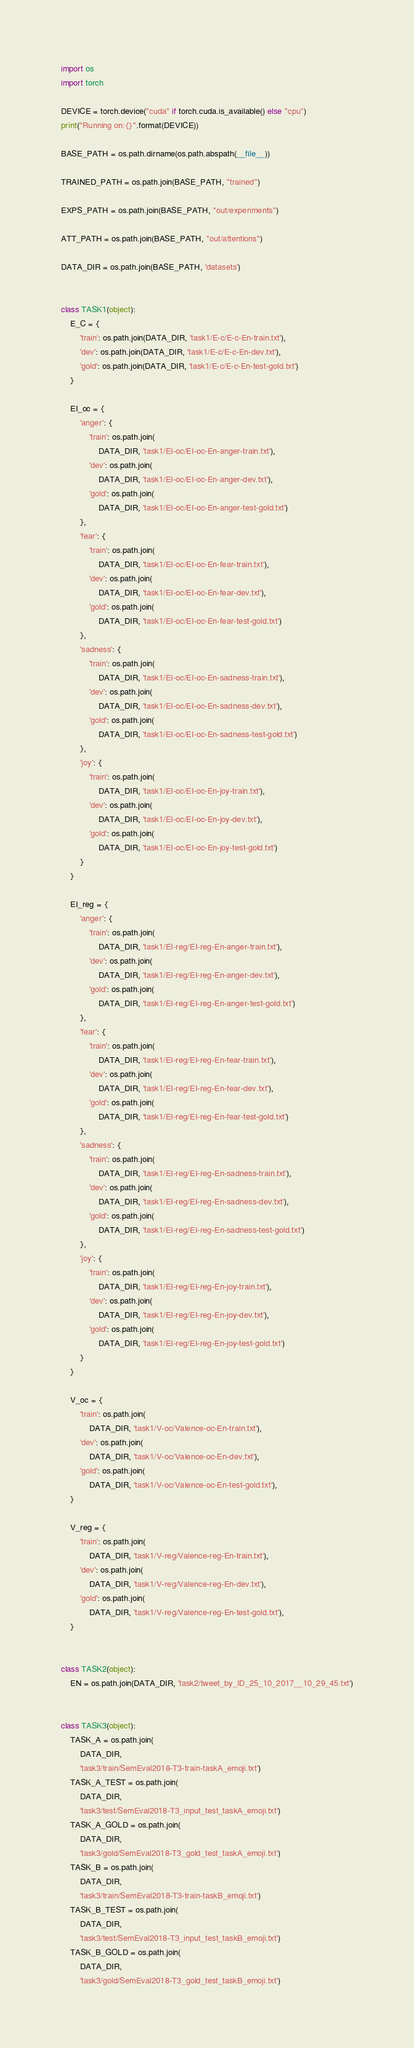<code> <loc_0><loc_0><loc_500><loc_500><_Python_>import os
import torch

DEVICE = torch.device("cuda" if torch.cuda.is_available() else "cpu")
print("Running on:{}".format(DEVICE))

BASE_PATH = os.path.dirname(os.path.abspath(__file__))

TRAINED_PATH = os.path.join(BASE_PATH, "trained")

EXPS_PATH = os.path.join(BASE_PATH, "out/experiments")

ATT_PATH = os.path.join(BASE_PATH, "out/attentions")

DATA_DIR = os.path.join(BASE_PATH, 'datasets')


class TASK1(object):
    E_C = {
        'train': os.path.join(DATA_DIR, 'task1/E-c/E-c-En-train.txt'),
        'dev': os.path.join(DATA_DIR, 'task1/E-c/E-c-En-dev.txt'),
        'gold': os.path.join(DATA_DIR, 'task1/E-c/E-c-En-test-gold.txt')
    }

    EI_oc = {
        'anger': {
            'train': os.path.join(
                DATA_DIR, 'task1/EI-oc/EI-oc-En-anger-train.txt'),
            'dev': os.path.join(
                DATA_DIR, 'task1/EI-oc/EI-oc-En-anger-dev.txt'),
            'gold': os.path.join(
                DATA_DIR, 'task1/EI-oc/EI-oc-En-anger-test-gold.txt')
        },
        'fear': {
            'train': os.path.join(
                DATA_DIR, 'task1/EI-oc/EI-oc-En-fear-train.txt'),
            'dev': os.path.join(
                DATA_DIR, 'task1/EI-oc/EI-oc-En-fear-dev.txt'),
            'gold': os.path.join(
                DATA_DIR, 'task1/EI-oc/EI-oc-En-fear-test-gold.txt')
        },
        'sadness': {
            'train': os.path.join(
                DATA_DIR, 'task1/EI-oc/EI-oc-En-sadness-train.txt'),
            'dev': os.path.join(
                DATA_DIR, 'task1/EI-oc/EI-oc-En-sadness-dev.txt'),
            'gold': os.path.join(
                DATA_DIR, 'task1/EI-oc/EI-oc-En-sadness-test-gold.txt')
        },
        'joy': {
            'train': os.path.join(
                DATA_DIR, 'task1/EI-oc/EI-oc-En-joy-train.txt'),
            'dev': os.path.join(
                DATA_DIR, 'task1/EI-oc/EI-oc-En-joy-dev.txt'),
            'gold': os.path.join(
                DATA_DIR, 'task1/EI-oc/EI-oc-En-joy-test-gold.txt')
        }
    }

    EI_reg = {
        'anger': {
            'train': os.path.join(
                DATA_DIR, 'task1/EI-reg/EI-reg-En-anger-train.txt'),
            'dev': os.path.join(
                DATA_DIR, 'task1/EI-reg/EI-reg-En-anger-dev.txt'),
            'gold': os.path.join(
                DATA_DIR, 'task1/EI-reg/EI-reg-En-anger-test-gold.txt')
        },
        'fear': {
            'train': os.path.join(
                DATA_DIR, 'task1/EI-reg/EI-reg-En-fear-train.txt'),
            'dev': os.path.join(
                DATA_DIR, 'task1/EI-reg/EI-reg-En-fear-dev.txt'),
            'gold': os.path.join(
                DATA_DIR, 'task1/EI-reg/EI-reg-En-fear-test-gold.txt')
        },
        'sadness': {
            'train': os.path.join(
                DATA_DIR, 'task1/EI-reg/EI-reg-En-sadness-train.txt'),
            'dev': os.path.join(
                DATA_DIR, 'task1/EI-reg/EI-reg-En-sadness-dev.txt'),
            'gold': os.path.join(
                DATA_DIR, 'task1/EI-reg/EI-reg-En-sadness-test-gold.txt')
        },
        'joy': {
            'train': os.path.join(
                DATA_DIR, 'task1/EI-reg/EI-reg-En-joy-train.txt'),
            'dev': os.path.join(
                DATA_DIR, 'task1/EI-reg/EI-reg-En-joy-dev.txt'),
            'gold': os.path.join(
                DATA_DIR, 'task1/EI-reg/EI-reg-En-joy-test-gold.txt')
        }
    }

    V_oc = {
        'train': os.path.join(
            DATA_DIR, 'task1/V-oc/Valence-oc-En-train.txt'),
        'dev': os.path.join(
            DATA_DIR, 'task1/V-oc/Valence-oc-En-dev.txt'),
        'gold': os.path.join(
            DATA_DIR, 'task1/V-oc/Valence-oc-En-test-gold.txt'),
    }

    V_reg = {
        'train': os.path.join(
            DATA_DIR, 'task1/V-reg/Valence-reg-En-train.txt'),
        'dev': os.path.join(
            DATA_DIR, 'task1/V-reg/Valence-reg-En-dev.txt'),
        'gold': os.path.join(
            DATA_DIR, 'task1/V-reg/Valence-reg-En-test-gold.txt'),
    }


class TASK2(object):
    EN = os.path.join(DATA_DIR, 'task2/tweet_by_ID_25_10_2017__10_29_45.txt')


class TASK3(object):
    TASK_A = os.path.join(
        DATA_DIR,
        'task3/train/SemEval2018-T3-train-taskA_emoji.txt')
    TASK_A_TEST = os.path.join(
        DATA_DIR,
        'task3/test/SemEval2018-T3_input_test_taskA_emoji.txt')
    TASK_A_GOLD = os.path.join(
        DATA_DIR,
        'task3/gold/SemEval2018-T3_gold_test_taskA_emoji.txt')
    TASK_B = os.path.join(
        DATA_DIR,
        'task3/train/SemEval2018-T3-train-taskB_emoji.txt')
    TASK_B_TEST = os.path.join(
        DATA_DIR,
        'task3/test/SemEval2018-T3_input_test_taskB_emoji.txt')
    TASK_B_GOLD = os.path.join(
        DATA_DIR,
        'task3/gold/SemEval2018-T3_gold_test_taskB_emoji.txt')
</code> 